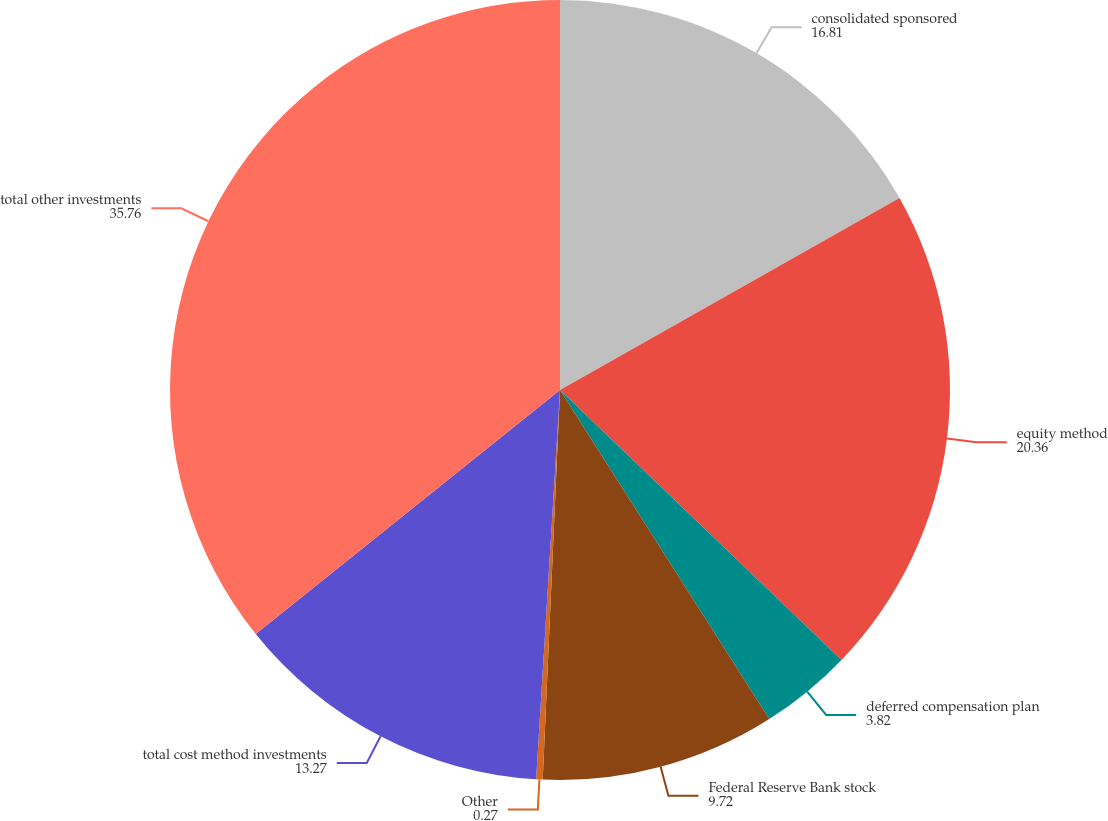<chart> <loc_0><loc_0><loc_500><loc_500><pie_chart><fcel>consolidated sponsored<fcel>equity method<fcel>deferred compensation plan<fcel>Federal Reserve Bank stock<fcel>Other<fcel>total cost method investments<fcel>total other investments<nl><fcel>16.81%<fcel>20.36%<fcel>3.82%<fcel>9.72%<fcel>0.27%<fcel>13.27%<fcel>35.76%<nl></chart> 